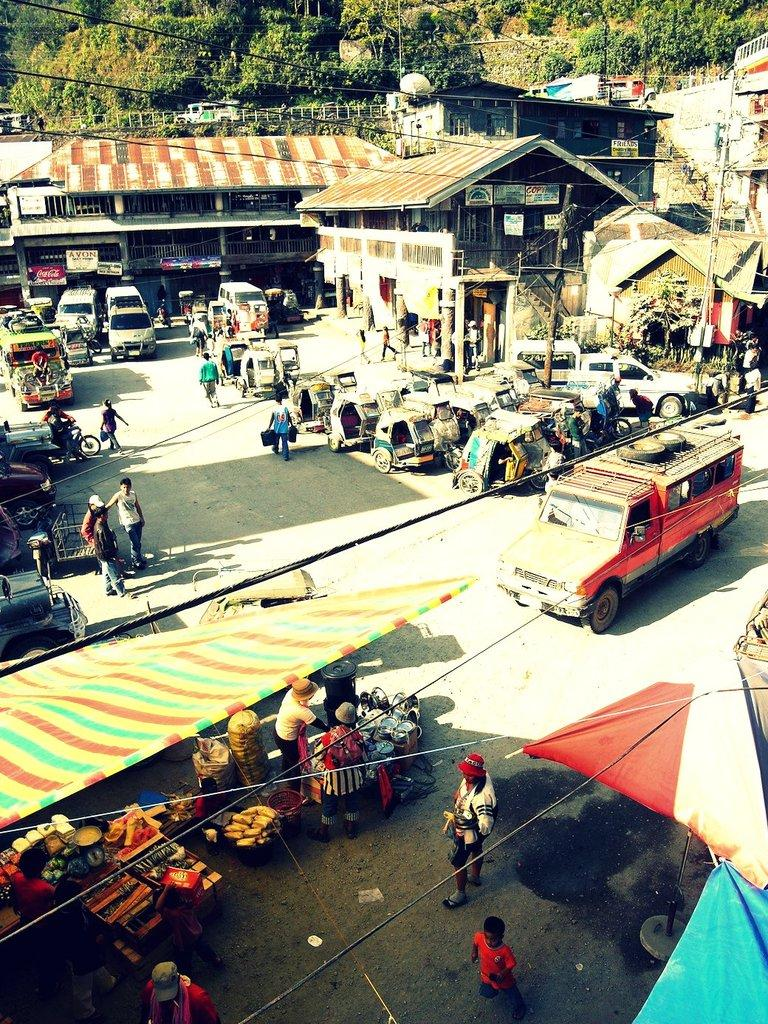What is the main feature in the center of the image? There is a road in the center of the image. What is happening on the road? There are vehicles on the road. What else can be seen in the image besides the road and vehicles? There are stalls and people walking in the image. What is visible in the background of the image? There are houses and trees in the background of the image. How many cats are sitting on the power lines in the image? There are no cats or power lines present in the image. What type of shoe is being used to measure the height of the trees in the image? There is no shoe or measurement of tree height in the image. 